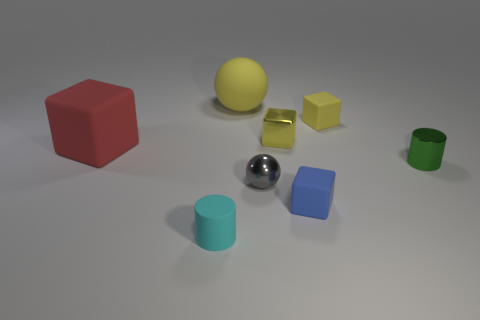Are there any small rubber cubes in front of the gray metal ball?
Provide a short and direct response. Yes. Does the cyan matte cylinder have the same size as the green metal thing?
Give a very brief answer. Yes. What number of yellow balls are the same material as the big red object?
Your answer should be very brief. 1. There is a sphere that is behind the cylinder that is on the right side of the blue rubber thing; what size is it?
Your answer should be compact. Large. There is a small matte object that is both in front of the green metal cylinder and right of the matte sphere; what color is it?
Give a very brief answer. Blue. Is the small green metal object the same shape as the tiny blue rubber object?
Give a very brief answer. No. The rubber ball that is the same color as the metallic cube is what size?
Make the answer very short. Large. What is the shape of the object that is on the left side of the small cylinder to the left of the yellow rubber block?
Your response must be concise. Cube. Do the tiny blue object and the large rubber thing in front of the tiny yellow shiny block have the same shape?
Your response must be concise. Yes. There is a shiny cylinder that is the same size as the gray shiny thing; what is its color?
Offer a terse response. Green. 